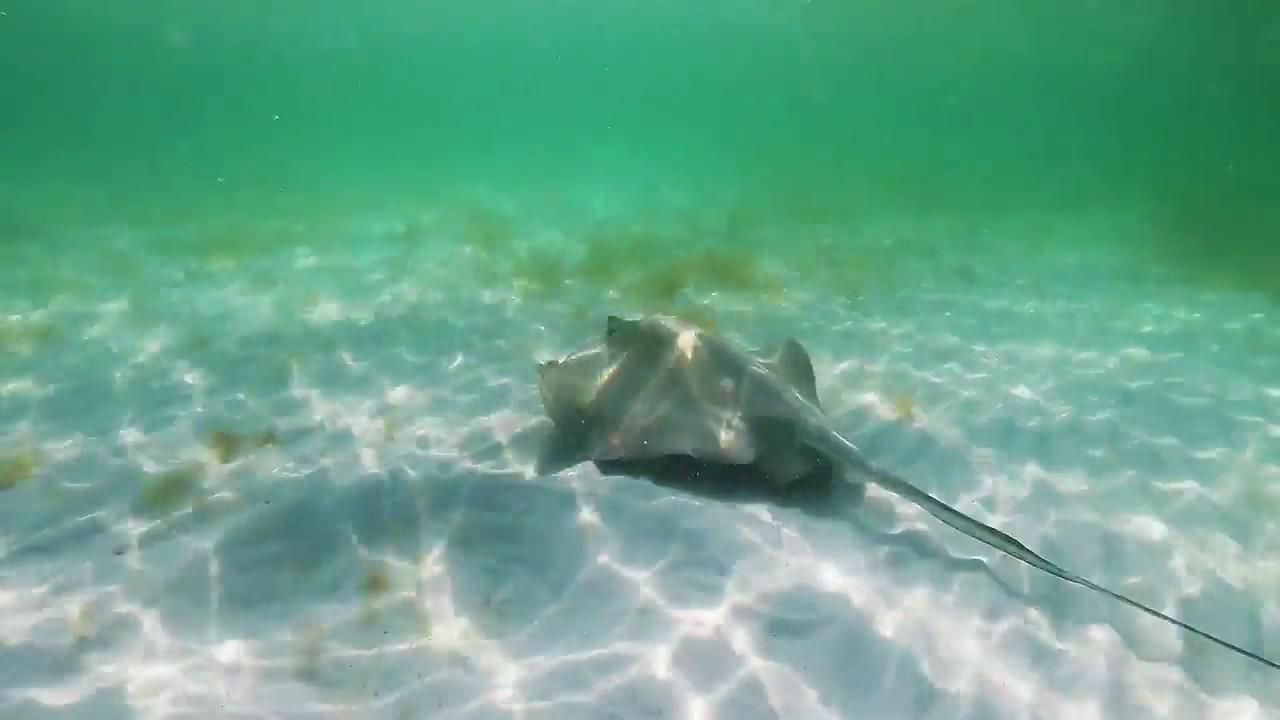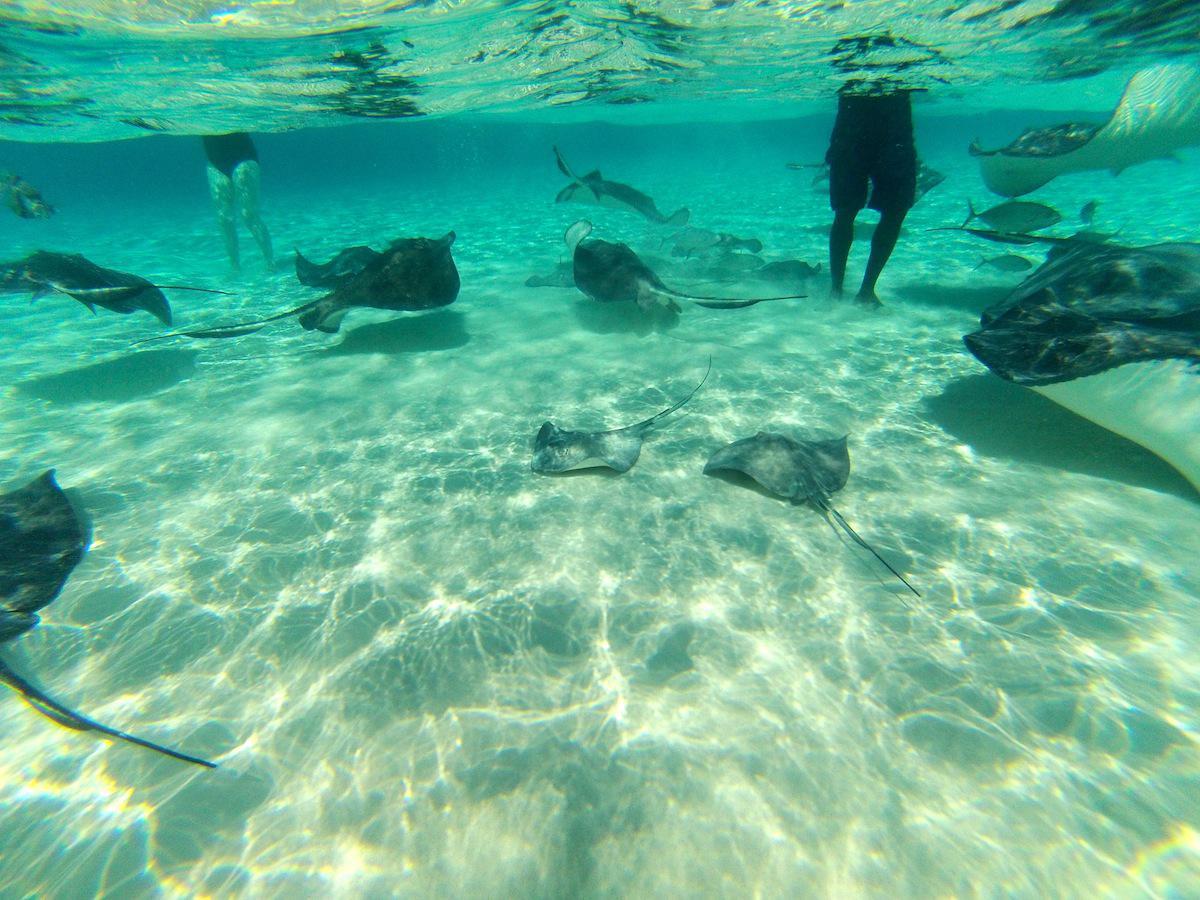The first image is the image on the left, the second image is the image on the right. For the images displayed, is the sentence "At least one human is standig in water where stingray are swimming." factually correct? Answer yes or no. Yes. The first image is the image on the left, the second image is the image on the right. For the images displayed, is the sentence "There is a man, standing among the manta rays." factually correct? Answer yes or no. Yes. 